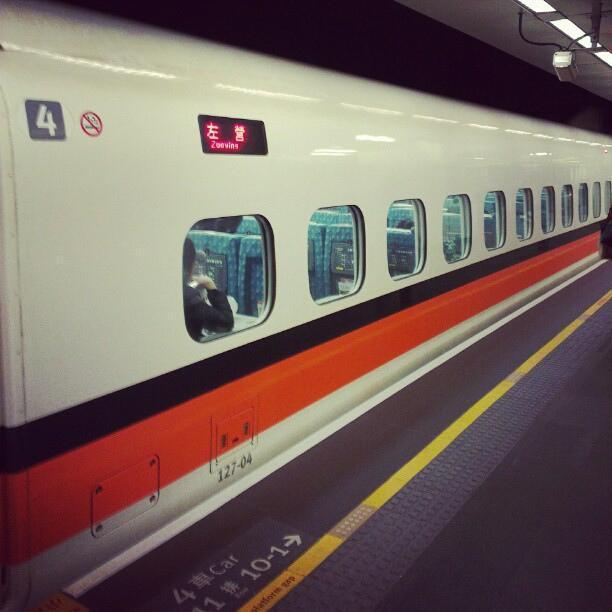How many windows on the train?
Give a very brief answer. 11. How many of the fruit that can be seen in the bowl are bananas?
Give a very brief answer. 0. 